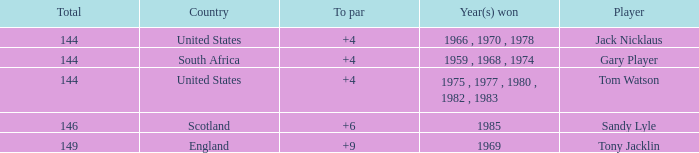What player had a To par smaller than 9 and won in 1985? Sandy Lyle. 